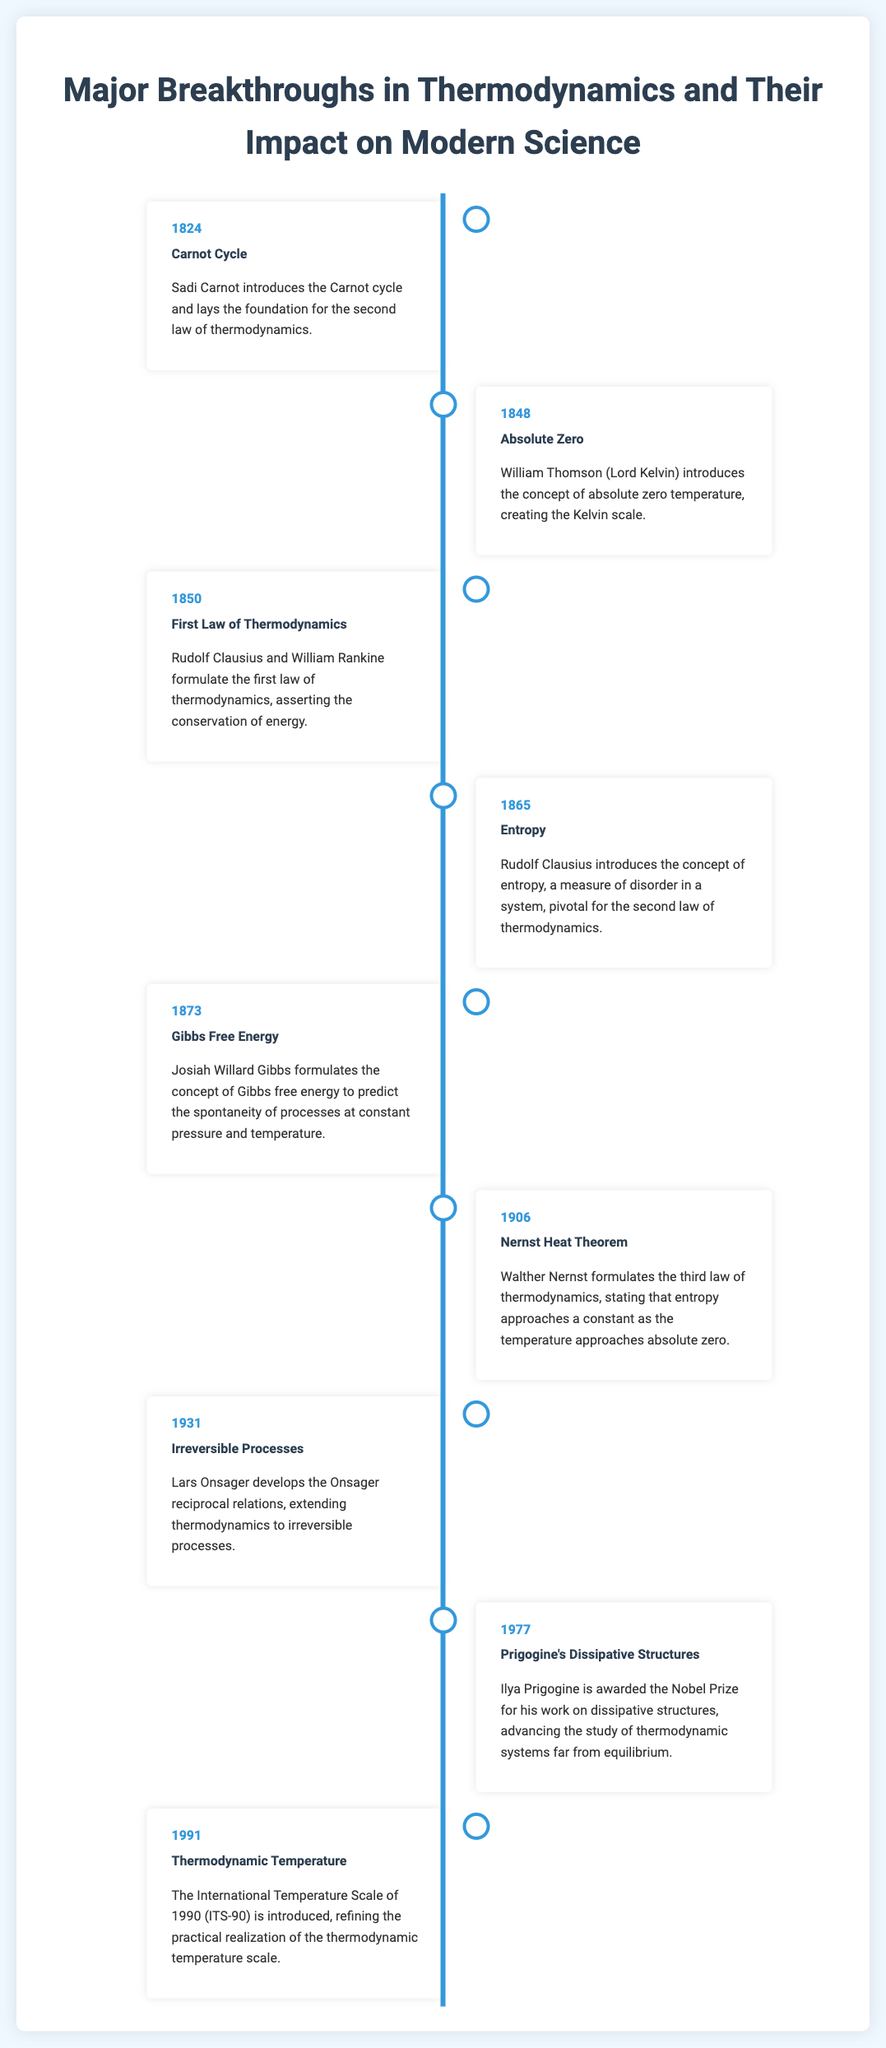What year was the Carnot cycle introduced? The Carnot cycle was introduced in 1824, as stated in the document.
Answer: 1824 Who formulated the first law of thermodynamics? The first law of thermodynamics was formulated by Rudolf Clausius and William Rankine.
Answer: Rudolf Clausius and William Rankine What concept did Rudolf Clausius introduce in 1865? In 1865, Rudolf Clausius introduced the concept of entropy.
Answer: Entropy What is the significance of the Gibbs free energy? The Gibbs free energy predicts the spontaneity of processes at constant pressure and temperature, as mentioned in the entry for 1873.
Answer: Predict spontaneity of processes at constant pressure and temperature Which law of thermodynamics mentions that entropy approaches a constant at absolute zero? The third law of thermodynamics states that entropy approaches a constant as the temperature approaches absolute zero, formulated in 1906.
Answer: Third law of thermodynamics What breakthrough in thermodynamics took place in 1977? In 1977, Ilya Prigogine was awarded the Nobel Prize for his work on dissipative structures.
Answer: Ilya Prigogine's Nobel Prize for dissipative structures What does the International Temperature Scale of 1990 refine? The ITS-90 refines the practical realization of the thermodynamic temperature scale, based on the information presented in the timeline.
Answer: Thermodynamic temperature scale What did Lars Onsager develop in 1931? Lars Onsager developed the Onsager reciprocal relations in 1931, extending thermodynamics to irreversible processes.
Answer: Onsager reciprocal relations 